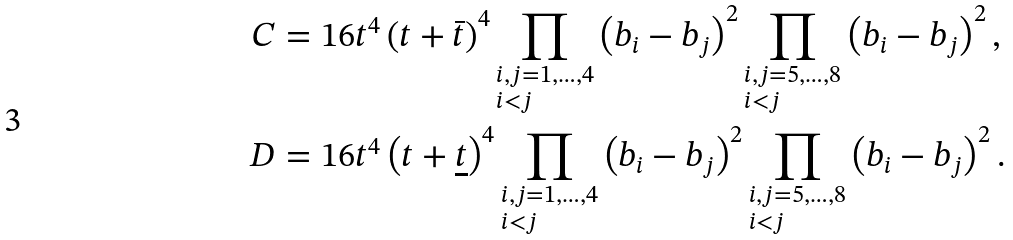<formula> <loc_0><loc_0><loc_500><loc_500>C & = 1 6 t ^ { 4 } \left ( t + \bar { t } \right ) ^ { 4 } \prod _ { \begin{subarray} { c } i , j = 1 , \dots , 4 \\ i < j \end{subarray} } \left ( b _ { i } - b _ { j } \right ) ^ { 2 } \prod _ { \begin{subarray} { c } i , j = 5 , \dots , 8 \\ i < j \end{subarray} } \left ( b _ { i } - b _ { j } \right ) ^ { 2 } , \\ D & = 1 6 t ^ { 4 } \left ( t + \underline { t } \right ) ^ { 4 } \prod _ { \begin{subarray} { c } i , j = 1 , \dots , 4 \\ i < j \end{subarray} } \left ( b _ { i } - b _ { j } \right ) ^ { 2 } \prod _ { \begin{subarray} { c } i , j = 5 , \dots , 8 \\ i < j \end{subarray} } \left ( b _ { i } - b _ { j } \right ) ^ { 2 } .</formula> 